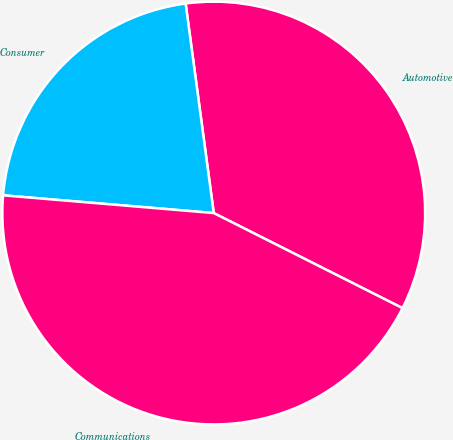<chart> <loc_0><loc_0><loc_500><loc_500><pie_chart><fcel>Automotive<fcel>Consumer<fcel>Communications<nl><fcel>34.55%<fcel>21.54%<fcel>43.91%<nl></chart> 